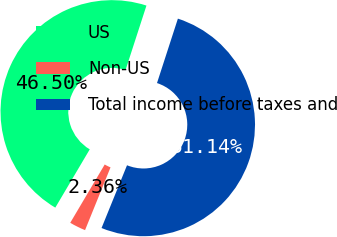Convert chart. <chart><loc_0><loc_0><loc_500><loc_500><pie_chart><fcel>US<fcel>Non-US<fcel>Total income before taxes and<nl><fcel>46.5%<fcel>2.36%<fcel>51.15%<nl></chart> 